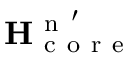<formula> <loc_0><loc_0><loc_500><loc_500>H _ { c o r e } ^ { n ^ { \prime } }</formula> 